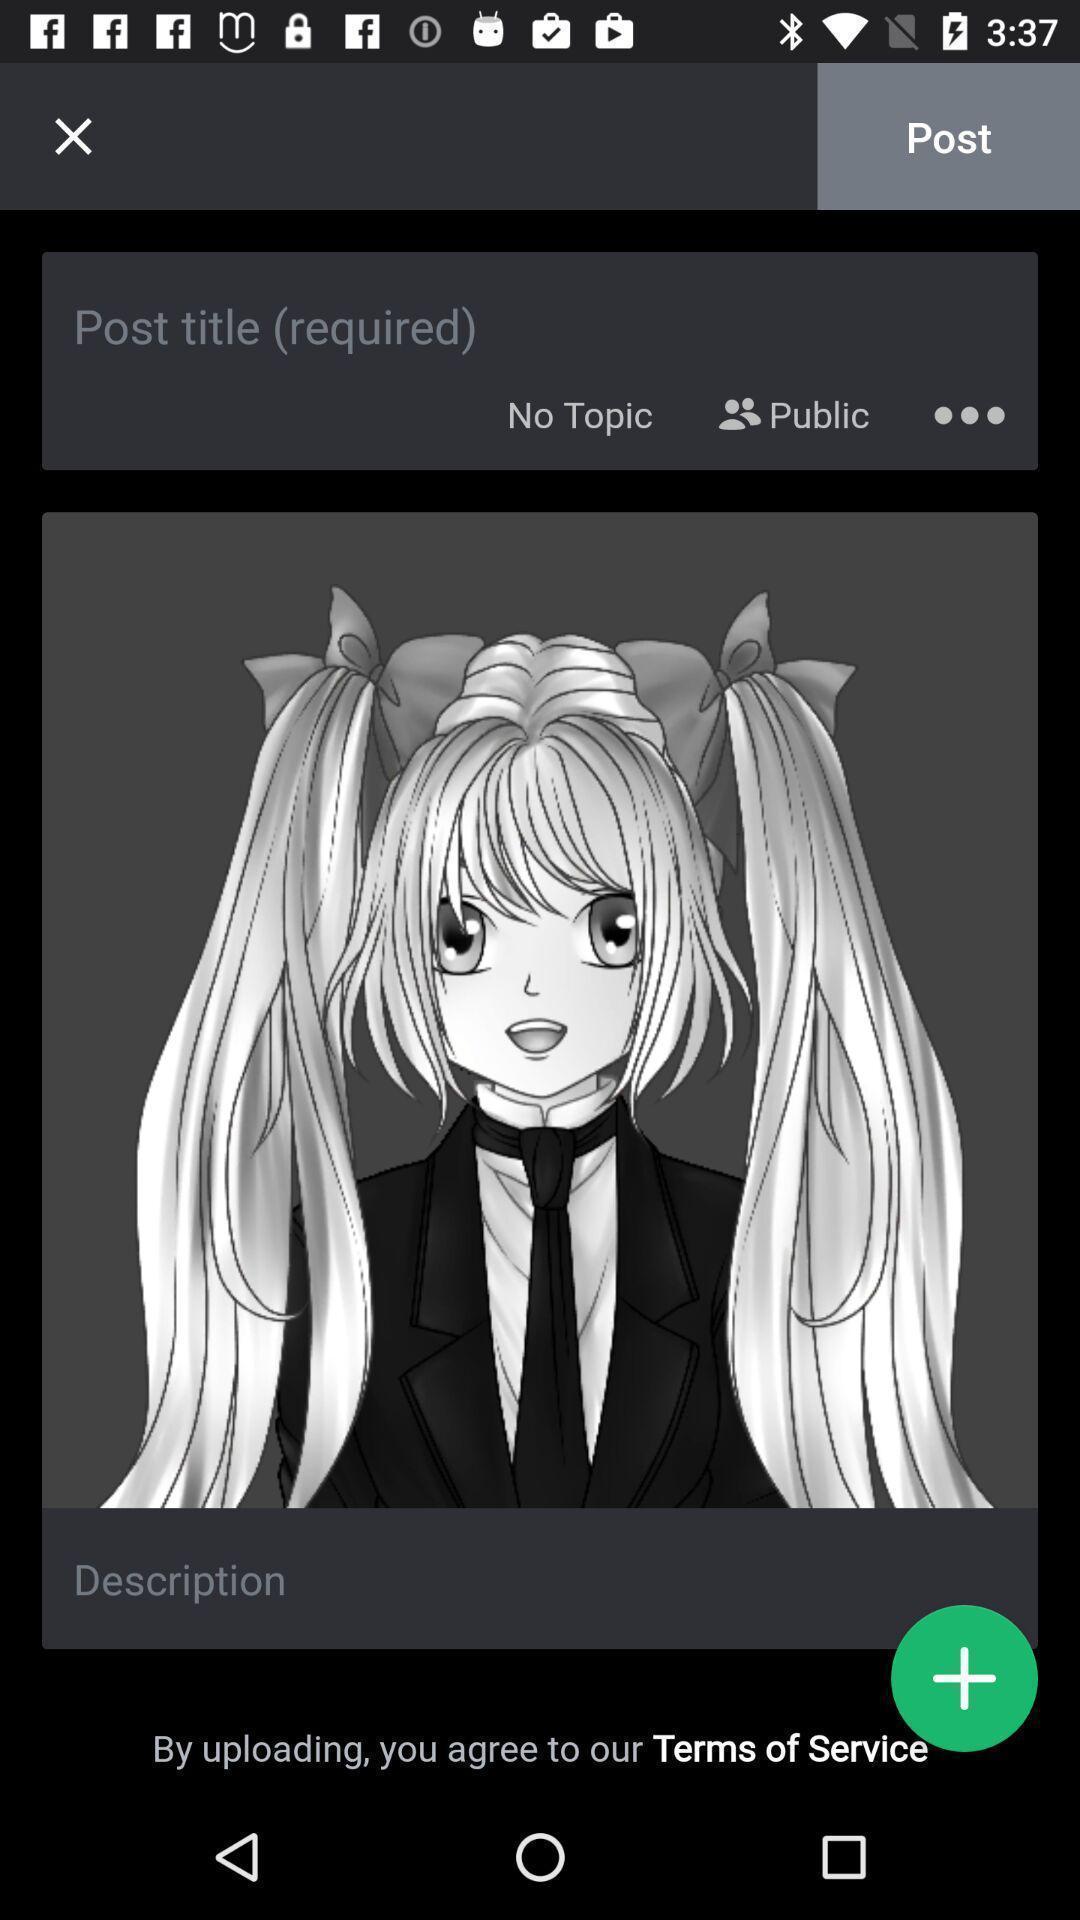What can you discern from this picture? Page showing an image of an animated girl. 